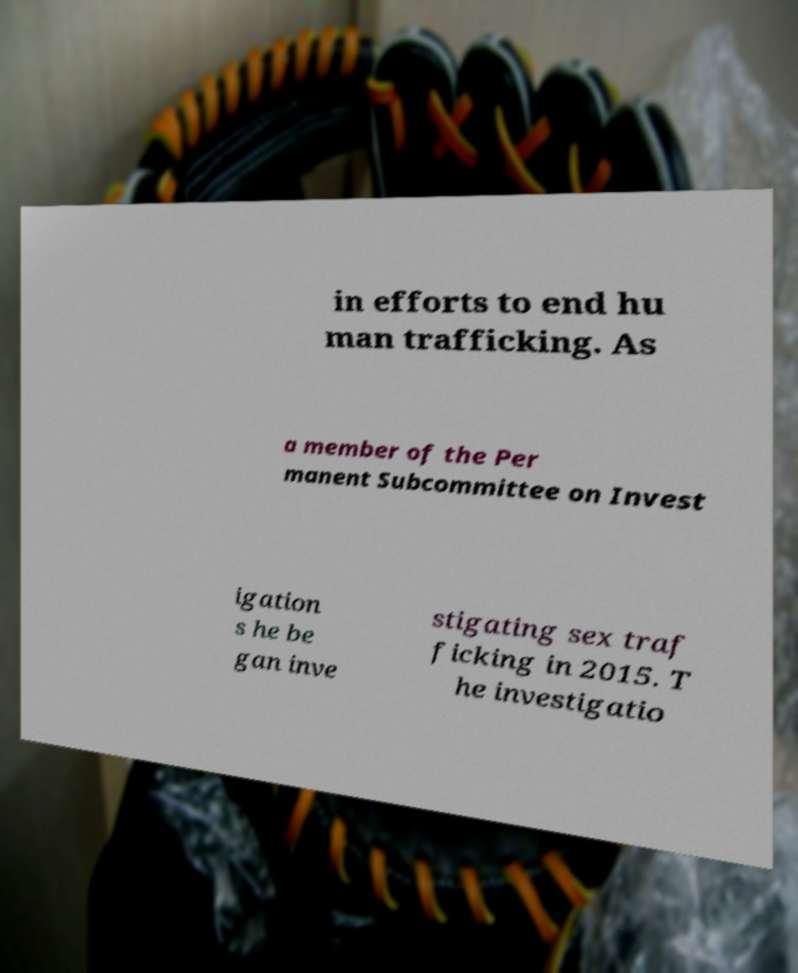Could you extract and type out the text from this image? in efforts to end hu man trafficking. As a member of the Per manent Subcommittee on Invest igation s he be gan inve stigating sex traf ficking in 2015. T he investigatio 